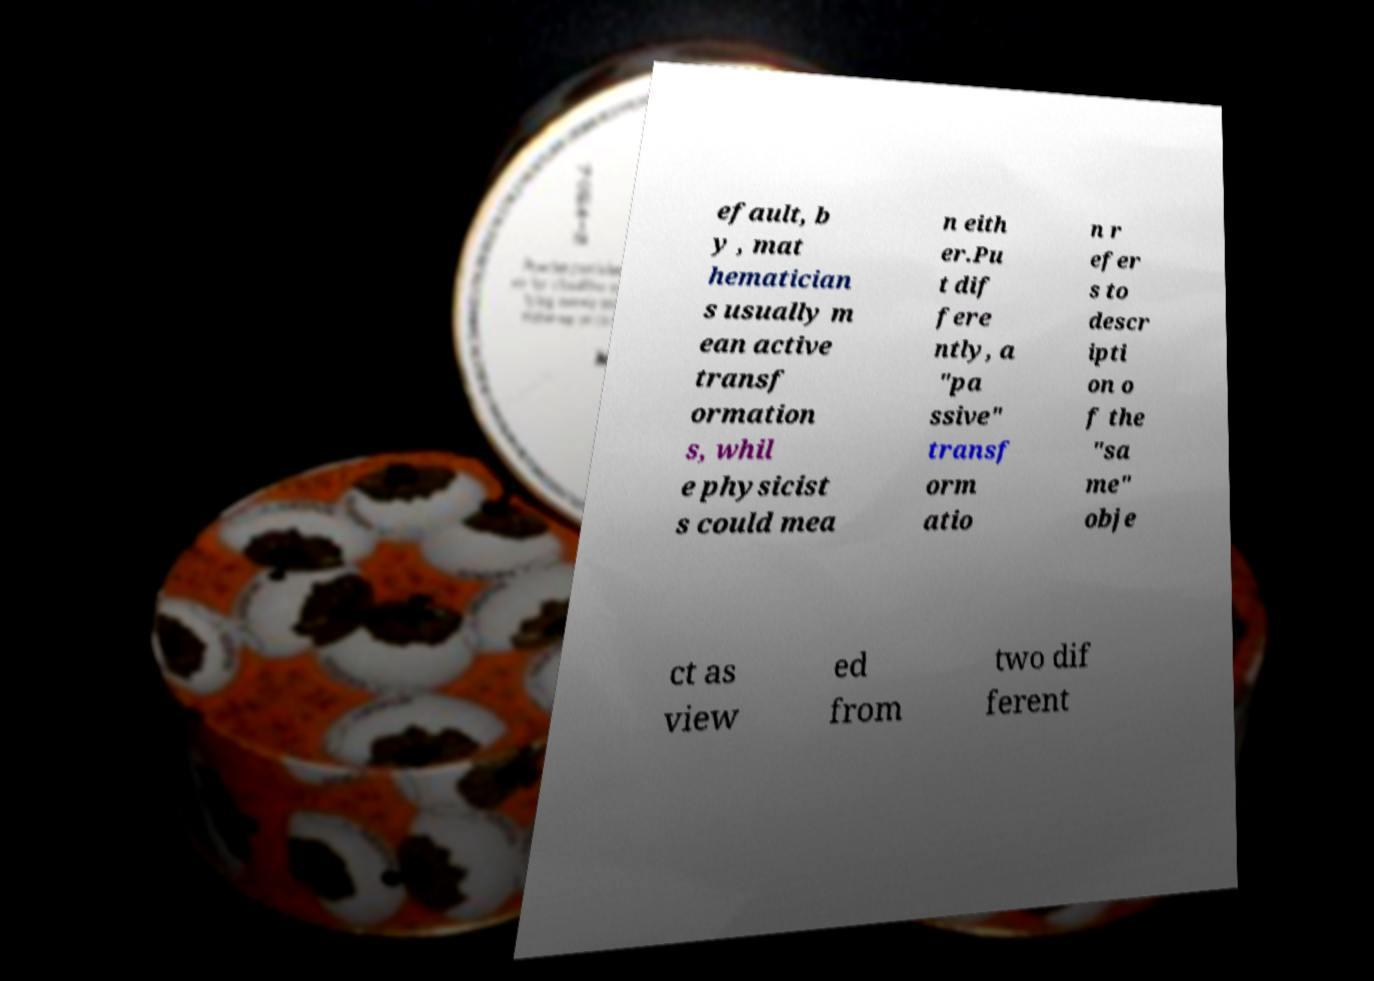Please identify and transcribe the text found in this image. efault, b y , mat hematician s usually m ean active transf ormation s, whil e physicist s could mea n eith er.Pu t dif fere ntly, a "pa ssive" transf orm atio n r efer s to descr ipti on o f the "sa me" obje ct as view ed from two dif ferent 